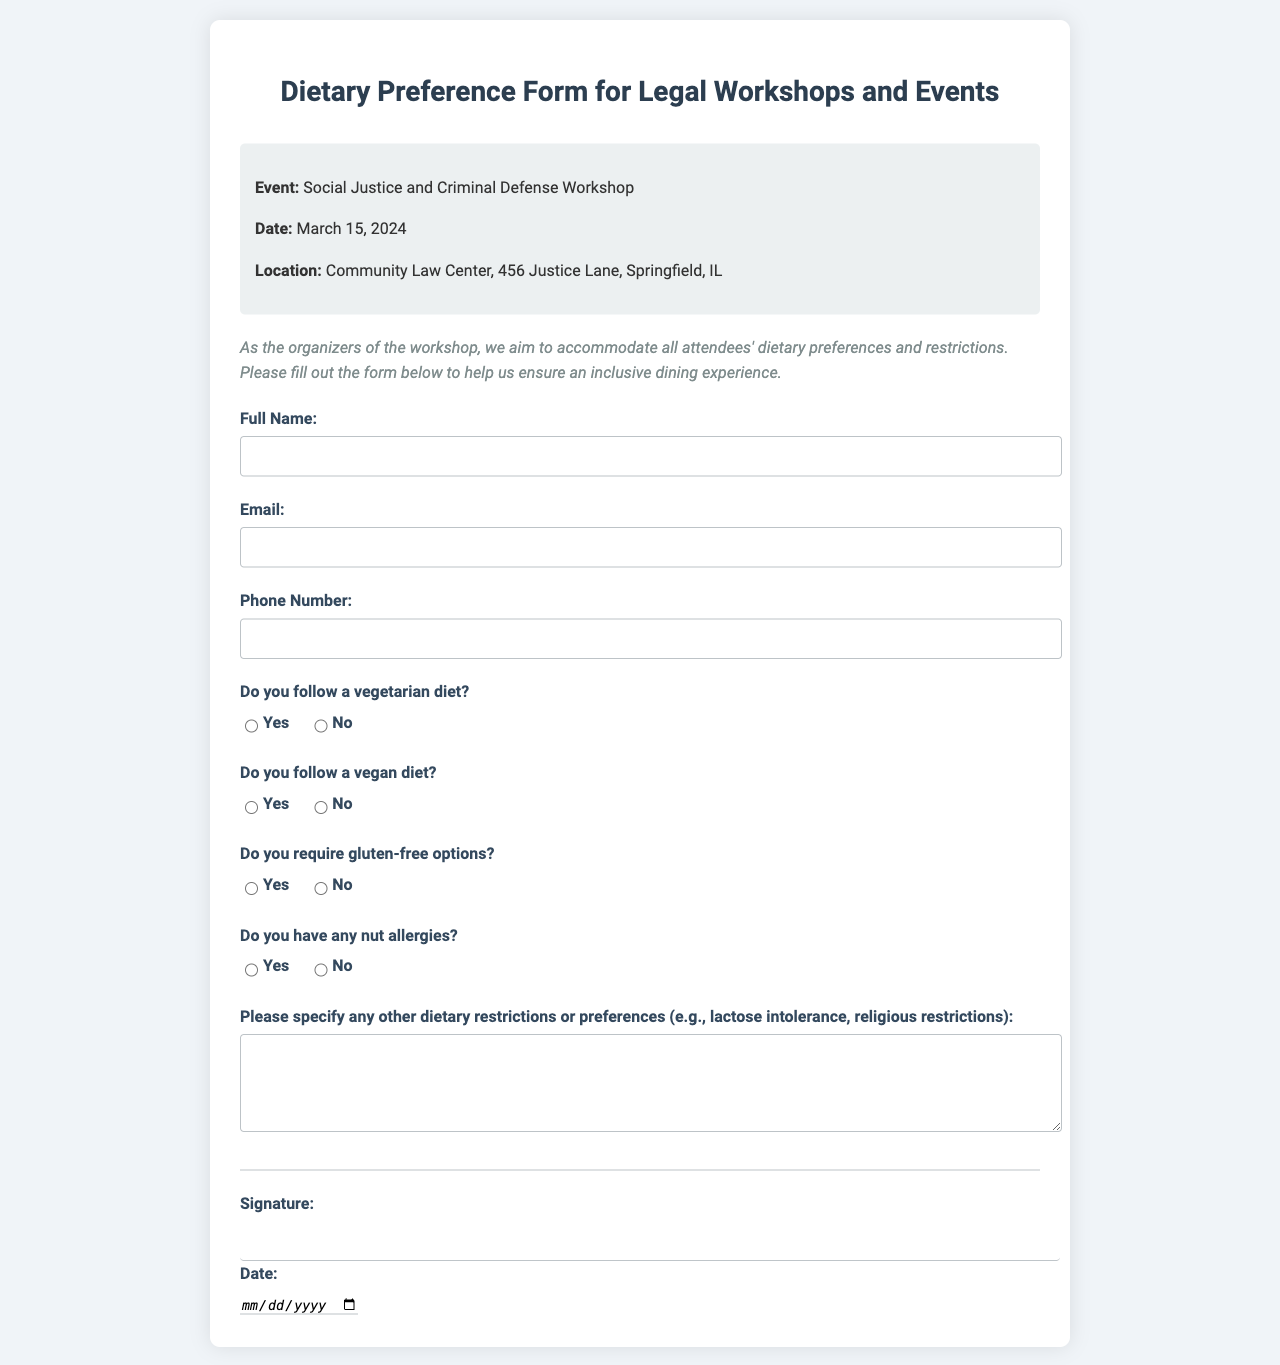What is the name of the event? The event is titled "Social Justice and Criminal Defense Workshop".
Answer: Social Justice and Criminal Defense Workshop What is the date of the event? The date mentioned in the document is March 15, 2024.
Answer: March 15, 2024 Where is the event located? The location provided is Community Law Center, 456 Justice Lane, Springfield, IL.
Answer: Community Law Center, 456 Justice Lane, Springfield, IL Is there an option for gluten-free food? The form asks if attendees require gluten-free options, indicating it's an option.
Answer: Yes What dietary preference does the form primarily address? The form focuses on vegetarian and vegan dietary preferences.
Answer: Vegetarian and vegan How can an attendee specify additional dietary restrictions? Attendees can specify other dietary restrictions in the text area labeled "Please specify any other dietary restrictions or preferences".
Answer: Through a text area What detail is required for the signature section? The form requires a signature and the date from the attendees.
Answer: Signature and date Is there a section for nut allergies? The form specifically includes a question regarding nut allergies for attendees.
Answer: Yes What is the font style used in the document? The document uses the 'Roboto' font for its content.
Answer: Roboto 